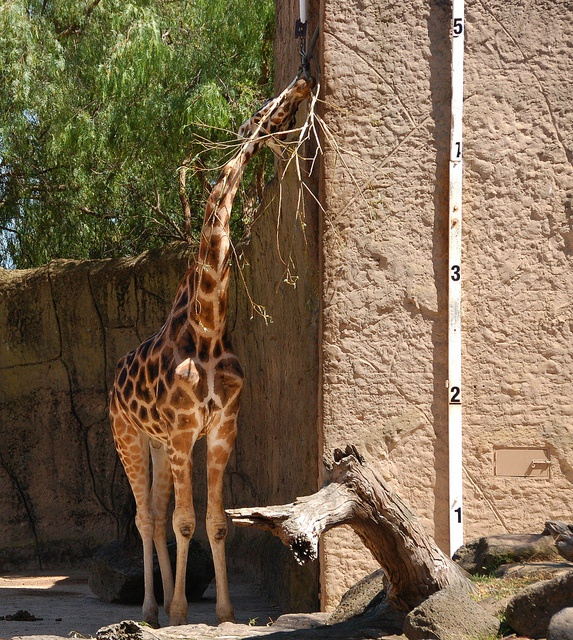Describe the objects in this image and their specific colors. I can see a giraffe in khaki, maroon, gray, brown, and black tones in this image. 